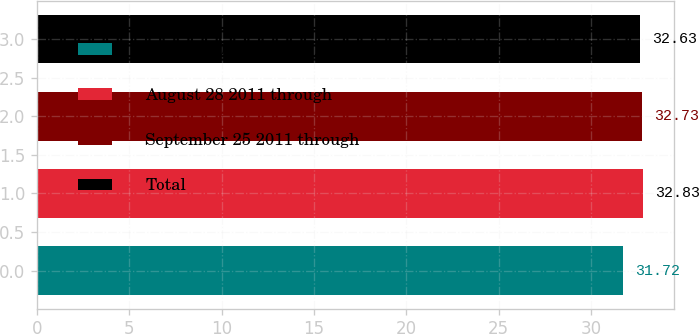Convert chart. <chart><loc_0><loc_0><loc_500><loc_500><bar_chart><fcel>July 31 2011 through August 27<fcel>August 28 2011 through<fcel>September 25 2011 through<fcel>Total<nl><fcel>31.72<fcel>32.83<fcel>32.73<fcel>32.63<nl></chart> 